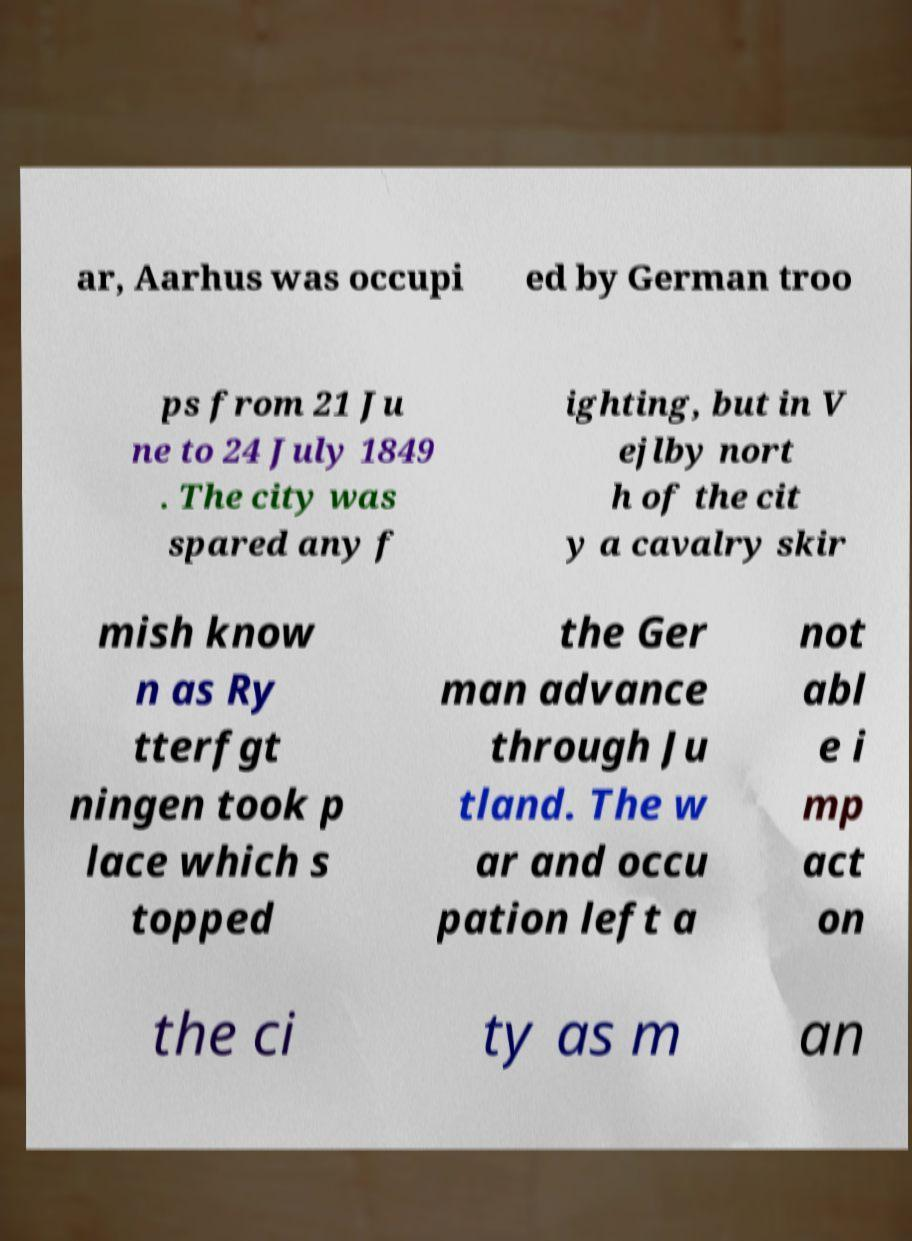I need the written content from this picture converted into text. Can you do that? ar, Aarhus was occupi ed by German troo ps from 21 Ju ne to 24 July 1849 . The city was spared any f ighting, but in V ejlby nort h of the cit y a cavalry skir mish know n as Ry tterfgt ningen took p lace which s topped the Ger man advance through Ju tland. The w ar and occu pation left a not abl e i mp act on the ci ty as m an 